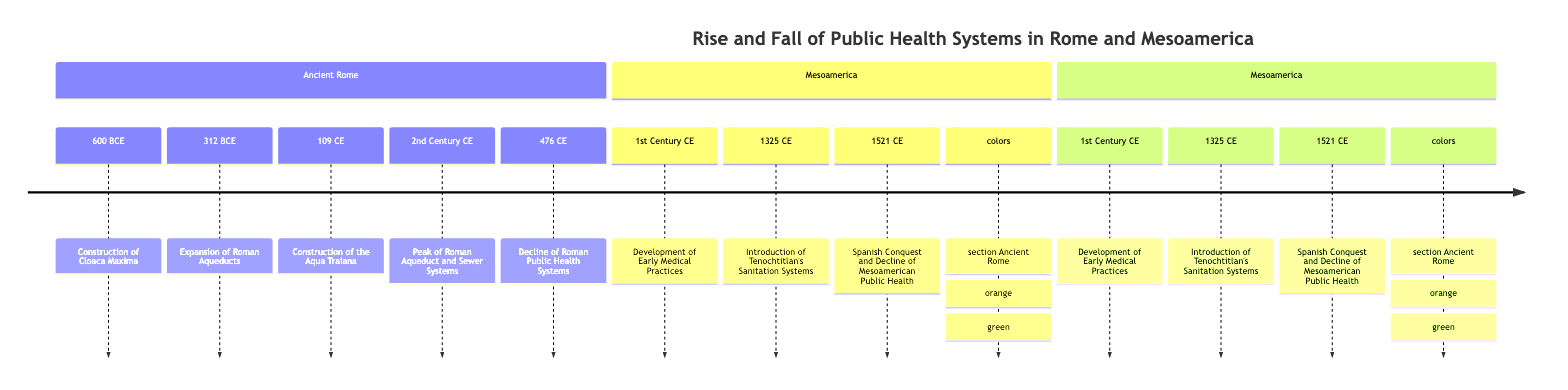What year did the construction of the Cloaca Maxima begin? The diagram indicates that the construction of the Cloaca Maxima began in 600 BCE.
Answer: 600 BCE What significant public health structure was built in 312 BCE? According to the timeline, the significant structure built in 312 BCE is the Aqua Appia, marking the expansion of Roman aqueducts.
Answer: Aqua Appia What was constructed during Emperor Trajan's reign? The Aqua Traiana was constructed during Emperor Trajan's reign, as indicated in the diagram for the year 109 CE.
Answer: Aqua Traiana What sanitation innovation was introduced in Tenochtitlan in 1325 CE? The timeline notes the introduction of advanced sanitation systems, which included aqueducts, canals, and public latrines in Tenochtitlan in 1325 CE.
Answer: Sanitation systems By what year did the peak of Roman aqueducts and sewer systems occur? The peak of Roman aqueduct and sewer systems occurred in the 2nd Century CE, as specified in the timeline.
Answer: 2nd Century CE What was the immediate result of the fall of the Western Roman Empire in 476 CE? Following the fall of the Western Roman Empire, the diagram shows a decline in the maintenance of aqueducts and sewage systems, leading to deteriorated public health conditions.
Answer: Deteriorated public health How did the Spanish conquest affect Mesoamerican public health? The timeline explains that the Spanish conquest in 1521 led to a decline in Mesoamerican public health systems, including their aqueducts and sanitation practices.
Answer: Decline in public health What two civilizations are referenced for their early medical practices in the 1st Century CE? The civilizations referenced for their early medical practices in the 1st Century CE are the Maya and Aztecs.
Answer: Maya and Aztecs How many aqueducts spanned over 415 km at the 2nd Century CE peak? By the 2nd Century CE, there were eleven aqueducts, as stated in the timeline element pertaining to the peak of these systems.
Answer: Eleven aqueducts 